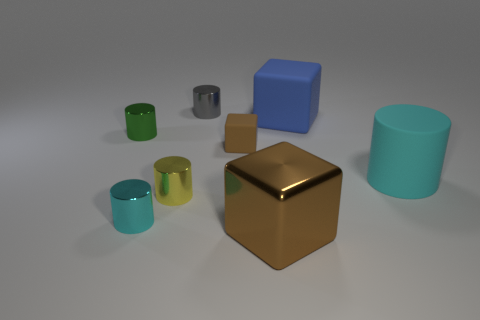The rubber thing that is the same color as the big metal cube is what shape?
Your response must be concise. Cube. Is there a big blue block that has the same material as the yellow cylinder?
Your answer should be very brief. No. Does the small green object in front of the blue cube have the same material as the tiny cylinder behind the small green shiny object?
Offer a terse response. Yes. Is the number of large cyan cylinders on the left side of the large cyan cylinder the same as the number of large cyan objects behind the small brown thing?
Make the answer very short. Yes. There is a block that is the same size as the gray cylinder; what is its color?
Offer a very short reply. Brown. Is there a large rubber object of the same color as the tiny cube?
Ensure brevity in your answer.  No. How many things are either things behind the tiny yellow metal cylinder or large purple shiny cylinders?
Provide a succinct answer. 5. What number of other objects are there of the same size as the yellow shiny object?
Provide a succinct answer. 4. What material is the large cube that is behind the cyan cylinder on the right side of the big cube in front of the large cyan rubber cylinder?
Make the answer very short. Rubber. What number of cubes are big blue objects or small yellow metal objects?
Provide a succinct answer. 1. 